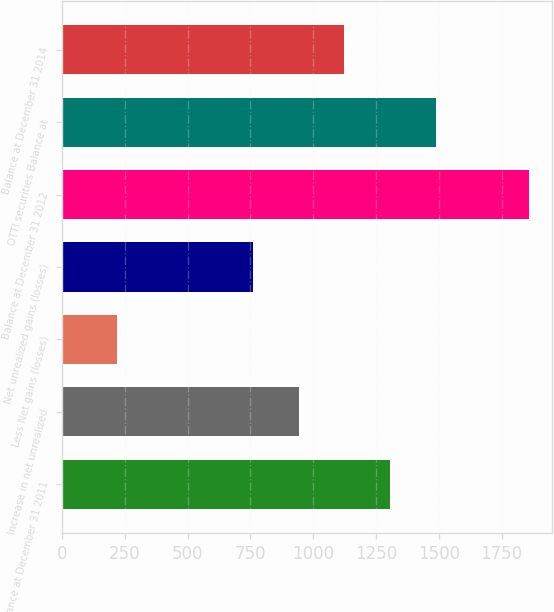Convert chart to OTSL. <chart><loc_0><loc_0><loc_500><loc_500><bar_chart><fcel>Balance at December 31 2011<fcel>Increase in net unrealized<fcel>Less Net gains (losses)<fcel>Net unrealized gains (losses)<fcel>Balance at December 31 2012<fcel>OTTI securities Balance at<fcel>Balance at December 31 2014<nl><fcel>1306.3<fcel>942.1<fcel>219.1<fcel>760<fcel>1858<fcel>1488.4<fcel>1124.2<nl></chart> 